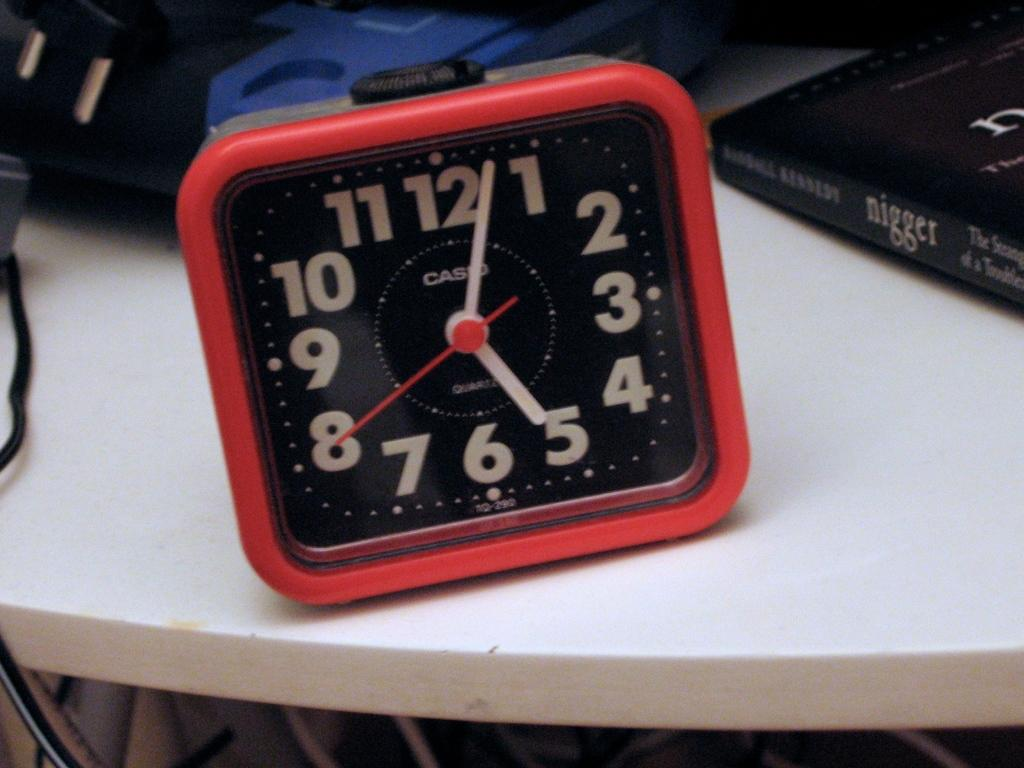What object in the image is used for measuring time? There is a clock in the image that is used for measuring time. What object in the image is used for reading or learning? There is a book in the image that is used for reading or learning. Where are the clock and the book located in the image? Both the clock and the book are placed on a table in the image. What type of education does the dad provide in the image? There is no dad present in the image, and therefore no education being provided. How does the book help with breathing in the image? The book does not have any direct impact on breathing in the image; it is an object for reading or learning. 